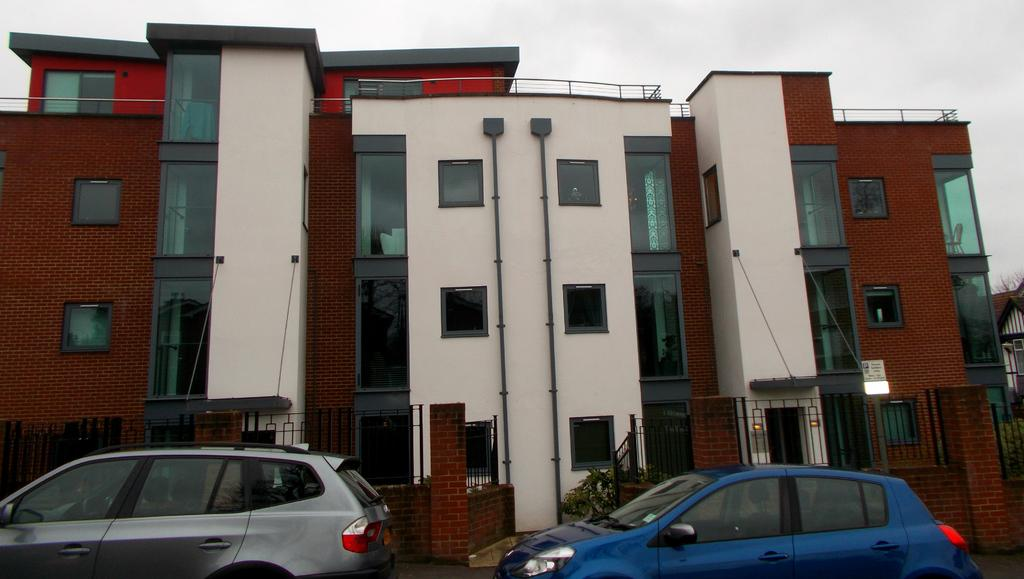What is located in the center of the image? There are buildings in the center of the image. What can be seen near the buildings? There is a railing and a wall in the image. What type of vehicles are at the bottom of the image? There are two vehicles at the bottom of the image. What is visible at the top of the image? The sky is visible at the top of the image. What type of bushes can be seen growing near the vehicles in the image? There are no bushes visible in the image; it only shows buildings, a railing, a wall, vehicles, and the sky. 